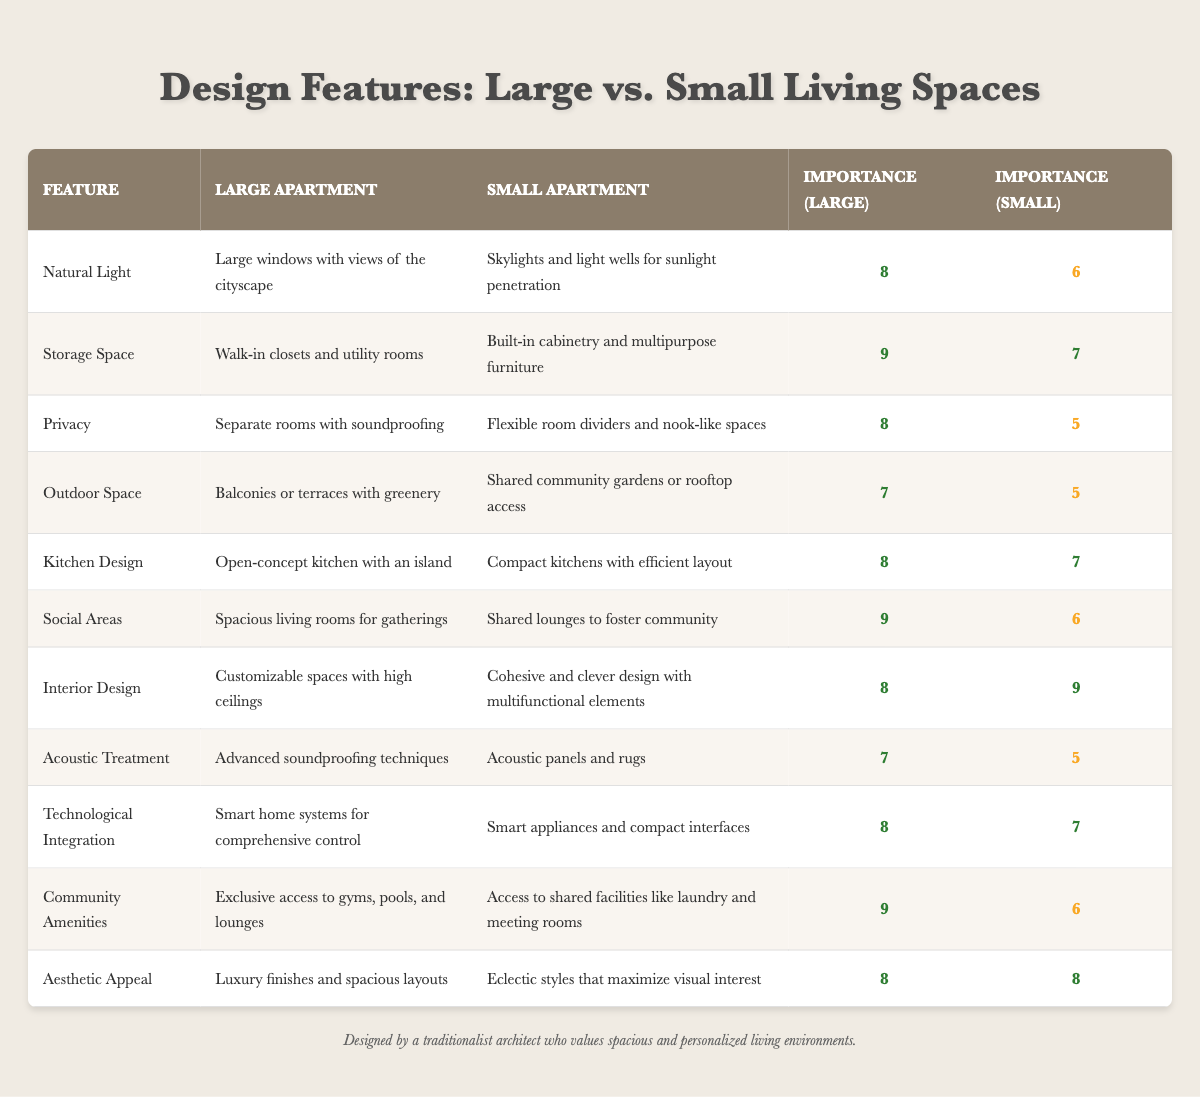What is the importance ratio of storage space in a large apartment? The importance ratio for storage space in a large apartment is listed directly in the table under the corresponding column, which shows it as 9.
Answer: 9 Which living space design feature has the highest importance ratio in small apartments? By reviewing the importance ratios in the small apartment column, the feature with the highest value is interior design, which has a ratio of 9.
Answer: Interior design Is the outdoor space feature regarded as more important in large apartments than in small ones? Comparing the importance ratio for outdoor space between large apartments (7) and small apartments (5), it clearly shows that outdoor space is regarded as more important in large apartments.
Answer: Yes What is the average importance ratio for community amenities in both types of apartments? To find the average, we add the importance ratios of community amenities: large (9) and small (6). The sum is 9 + 6 = 15, and then we divide by 2, resulting in 15/2 = 7.5.
Answer: 7.5 How does the privacy feature in large apartments differ from that in small apartments in terms of importance ratios? The privacy feature has an importance ratio of 8 in large apartments and 5 in small apartments. The difference between them is 8 - 5 = 3, showing that privacy is deemed significantly more important in large apartments.
Answer: 3 Do both living space types value aesthetic appeal equally? Looking at the importance ratios for aesthetic appeal in both apartment types, both large and small apartments have a ratio of 8, indicating that they value aesthetic appeal equally.
Answer: Yes Which feature in small apartments has an importance ratio lower than the corresponding feature in large apartments? By examining the table, features like natural light, privacy, outdoor space, social areas, and acoustic treatment in small apartments all have lower importance ratios compared to their large apartment counterparts.
Answer: Natural light, privacy, outdoor space, social areas, acoustic treatment What is the total importance ratio sum for kitchen design in both large and small apartments? We add the importance ratios for kitchen design: large apartment (8) and small apartment (7). Thus, the total is 8 + 7 = 15.
Answer: 15 How many features have a higher importance ratio in small apartments compared to large apartments? Reviewing the table shows that only one feature, interior design, has a higher importance ratio in small apartments (9) than in large apartments (8). Therefore, only one feature qualifies.
Answer: 1 